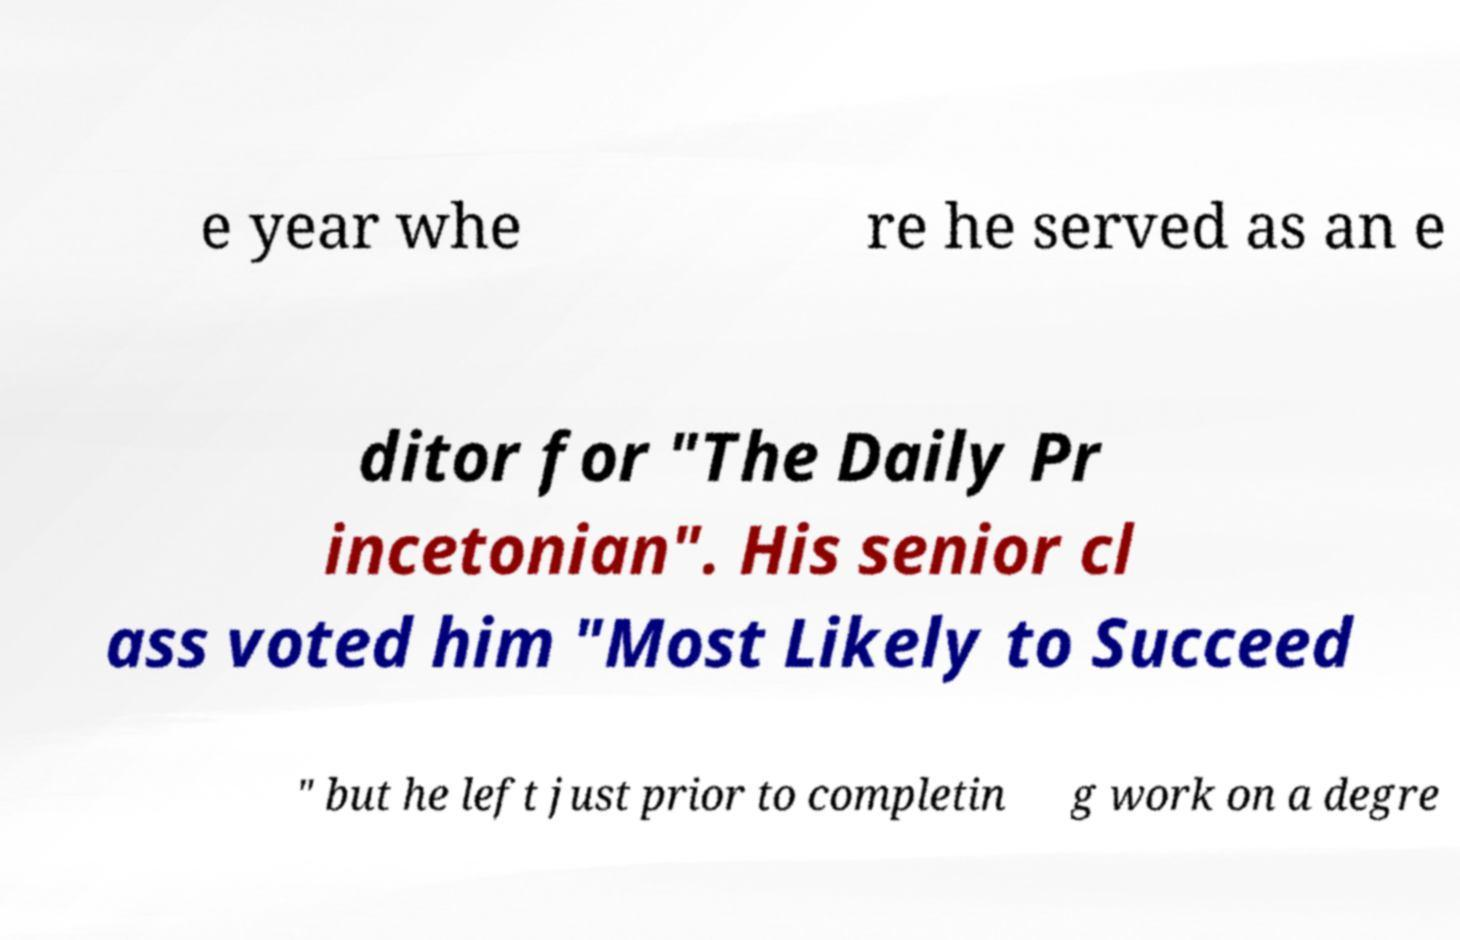There's text embedded in this image that I need extracted. Can you transcribe it verbatim? e year whe re he served as an e ditor for "The Daily Pr incetonian". His senior cl ass voted him "Most Likely to Succeed " but he left just prior to completin g work on a degre 